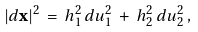<formula> <loc_0><loc_0><loc_500><loc_500>| d { \mathbf x } | ^ { 2 } \, = \, h _ { 1 } ^ { 2 } \, d u _ { 1 } ^ { 2 } \, + \, h _ { 2 } ^ { 2 } \, d u _ { 2 } ^ { 2 } \, ,</formula> 